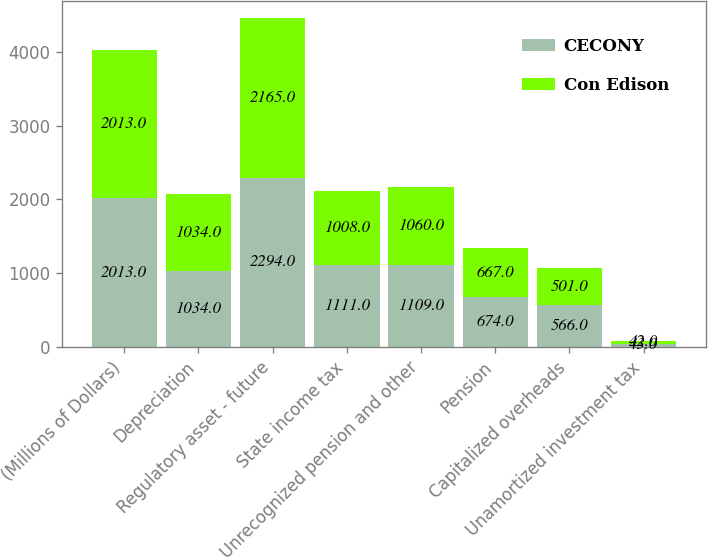Convert chart. <chart><loc_0><loc_0><loc_500><loc_500><stacked_bar_chart><ecel><fcel>(Millions of Dollars)<fcel>Depreciation<fcel>Regulatory asset - future<fcel>State income tax<fcel>Unrecognized pension and other<fcel>Pension<fcel>Capitalized overheads<fcel>Unamortized investment tax<nl><fcel>CECONY<fcel>2013<fcel>1034<fcel>2294<fcel>1111<fcel>1109<fcel>674<fcel>566<fcel>43<nl><fcel>Con Edison<fcel>2013<fcel>1034<fcel>2165<fcel>1008<fcel>1060<fcel>667<fcel>501<fcel>42<nl></chart> 